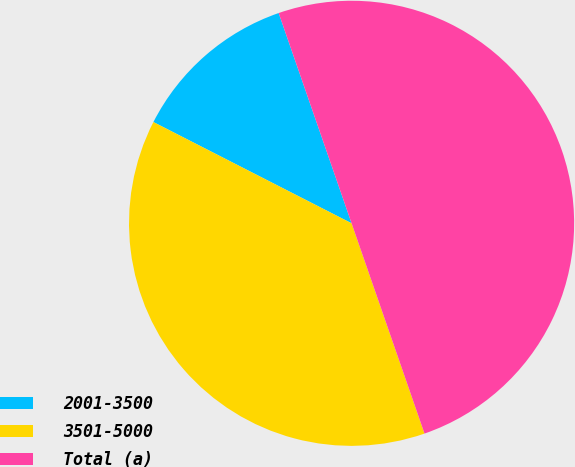Convert chart. <chart><loc_0><loc_0><loc_500><loc_500><pie_chart><fcel>2001-3500<fcel>3501-5000<fcel>Total (a)<nl><fcel>12.17%<fcel>37.83%<fcel>50.0%<nl></chart> 